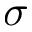Convert formula to latex. <formula><loc_0><loc_0><loc_500><loc_500>\sigma</formula> 